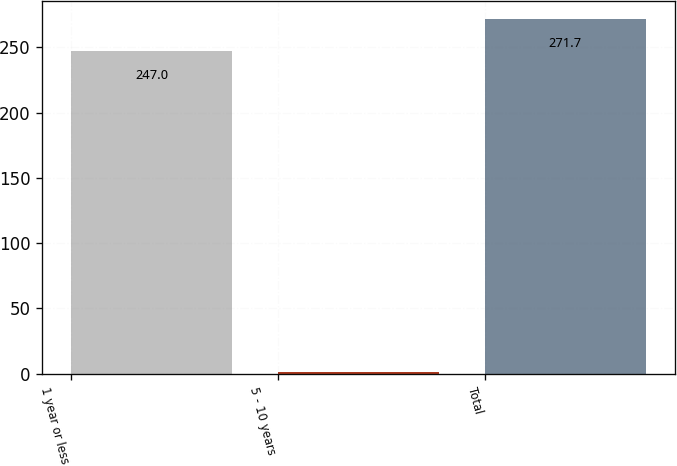<chart> <loc_0><loc_0><loc_500><loc_500><bar_chart><fcel>1 year or less<fcel>5 - 10 years<fcel>Total<nl><fcel>247<fcel>1<fcel>271.7<nl></chart> 